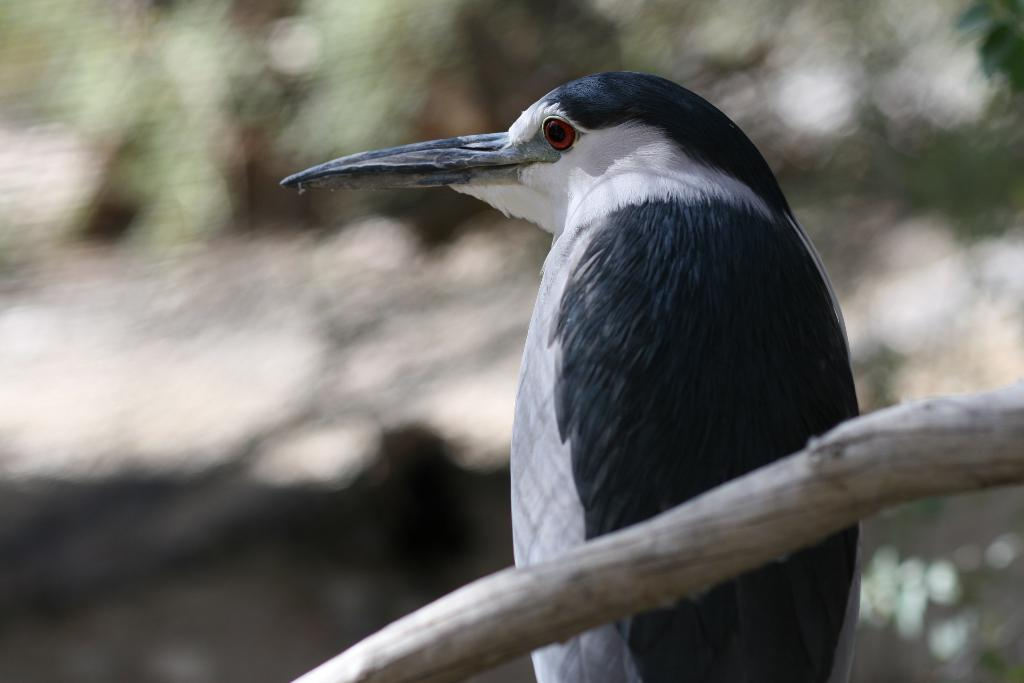What type of animal can be seen in the image? There is a bird in the image. Can you describe the background of the image? The background of the image is blurred. What disease is the bird suffering from in the image? There is no indication in the image that the bird is suffering from any disease. 